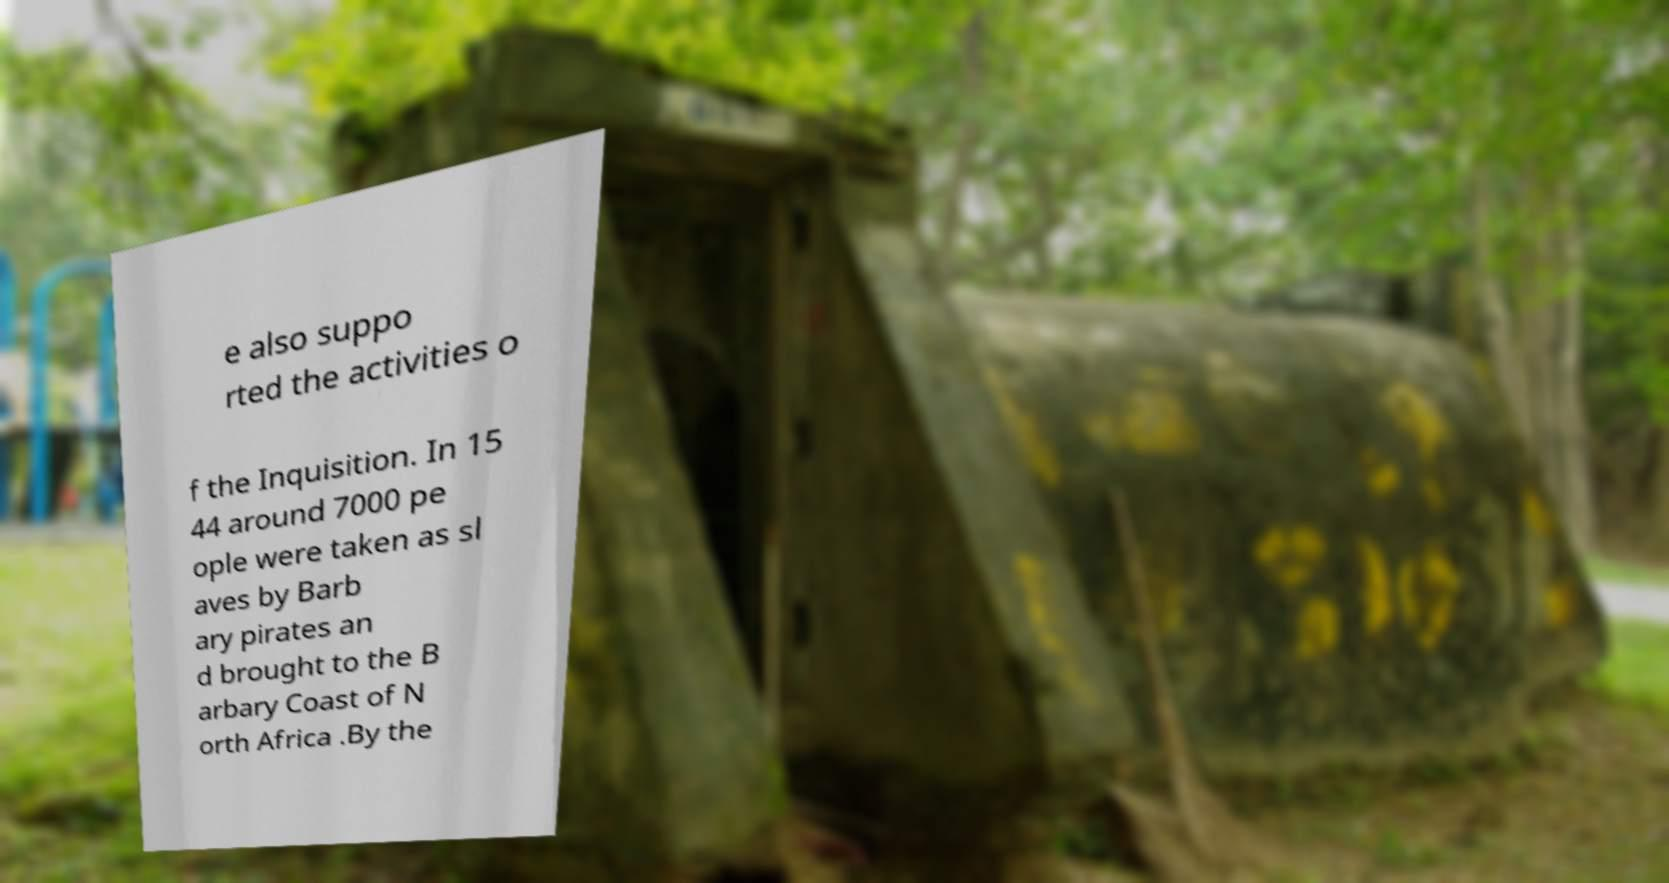I need the written content from this picture converted into text. Can you do that? e also suppo rted the activities o f the Inquisition. In 15 44 around 7000 pe ople were taken as sl aves by Barb ary pirates an d brought to the B arbary Coast of N orth Africa .By the 